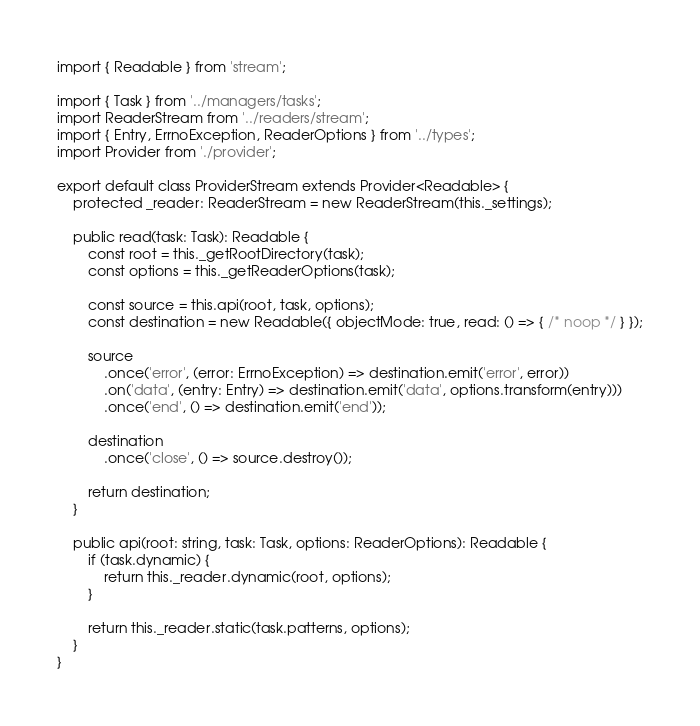<code> <loc_0><loc_0><loc_500><loc_500><_TypeScript_>import { Readable } from 'stream';

import { Task } from '../managers/tasks';
import ReaderStream from '../readers/stream';
import { Entry, ErrnoException, ReaderOptions } from '../types';
import Provider from './provider';

export default class ProviderStream extends Provider<Readable> {
	protected _reader: ReaderStream = new ReaderStream(this._settings);

	public read(task: Task): Readable {
		const root = this._getRootDirectory(task);
		const options = this._getReaderOptions(task);

		const source = this.api(root, task, options);
		const destination = new Readable({ objectMode: true, read: () => { /* noop */ } });

		source
			.once('error', (error: ErrnoException) => destination.emit('error', error))
			.on('data', (entry: Entry) => destination.emit('data', options.transform(entry)))
			.once('end', () => destination.emit('end'));

		destination
			.once('close', () => source.destroy());

		return destination;
	}

	public api(root: string, task: Task, options: ReaderOptions): Readable {
		if (task.dynamic) {
			return this._reader.dynamic(root, options);
		}

		return this._reader.static(task.patterns, options);
	}
}
</code> 